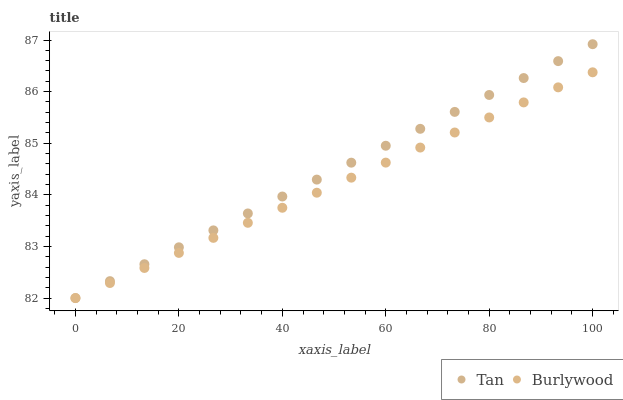Does Burlywood have the minimum area under the curve?
Answer yes or no. Yes. Does Tan have the maximum area under the curve?
Answer yes or no. Yes. Does Tan have the minimum area under the curve?
Answer yes or no. No. Is Burlywood the smoothest?
Answer yes or no. Yes. Is Tan the roughest?
Answer yes or no. Yes. Is Tan the smoothest?
Answer yes or no. No. Does Burlywood have the lowest value?
Answer yes or no. Yes. Does Tan have the highest value?
Answer yes or no. Yes. Does Tan intersect Burlywood?
Answer yes or no. Yes. Is Tan less than Burlywood?
Answer yes or no. No. Is Tan greater than Burlywood?
Answer yes or no. No. 